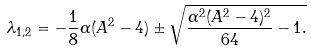<formula> <loc_0><loc_0><loc_500><loc_500>\lambda _ { 1 , 2 } = - \frac { 1 } { 8 } \alpha ( A ^ { 2 } - 4 ) \pm \sqrt { \frac { \alpha ^ { 2 } ( A ^ { 2 } - 4 ) ^ { 2 } } { 6 4 } - 1 . }</formula> 